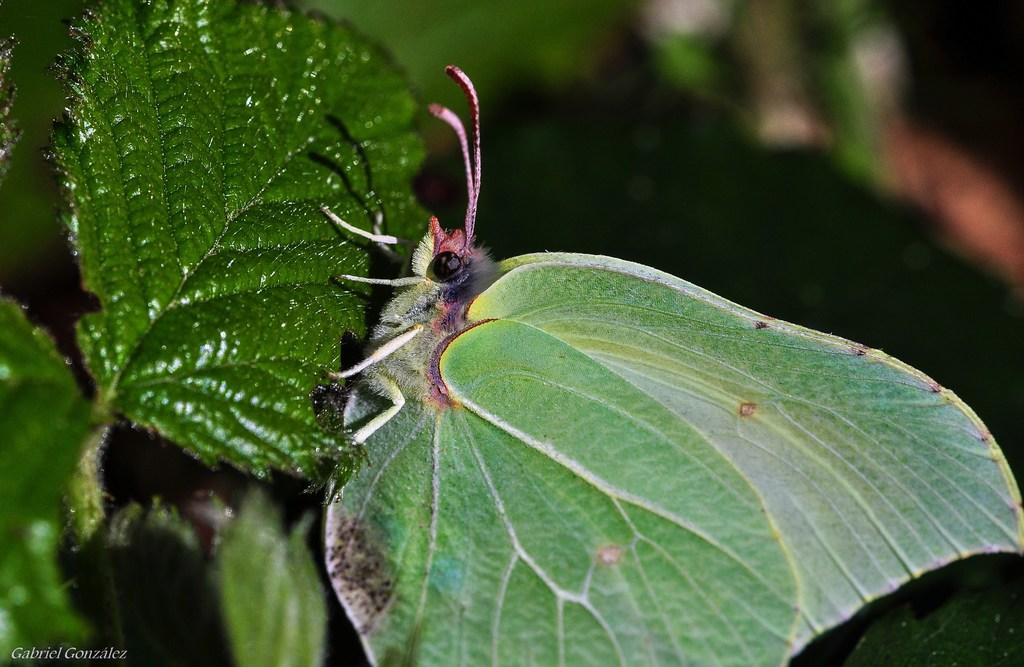What is the main subject of the image? There is a butterfly in the image. Where is the butterfly located? The butterfly is on a leaf. How close is the view of the butterfly in the image? The image provides a close-up view of the butterfly. What type of plants can be seen falling from the butterfly in the image? There are no plants falling from the butterfly in the image; it is simply resting on a leaf. 